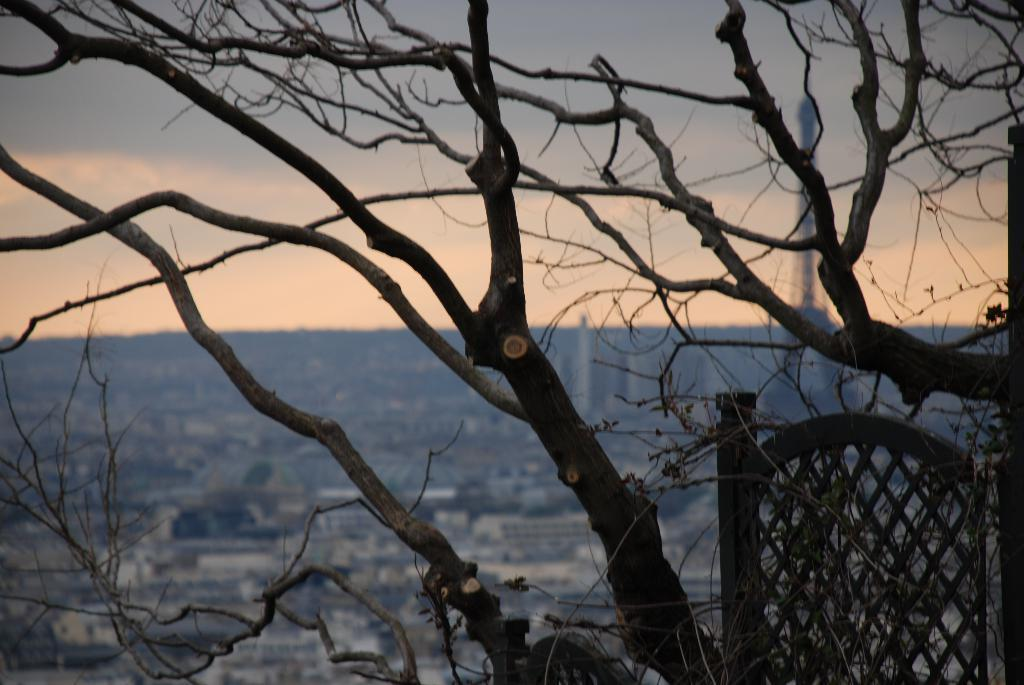What type of vegetation is present in the image? There are dried trees in the image. What can be seen in the distance behind the trees? There are buildings in the background of the image. What structure is located on the right side of the image? There is a tower on the right side of the image. What is visible in the sky in the image? The sky is visible in the background of the image. What type of breakfast is being served in the image? There is no breakfast present in the image; it features dried trees, buildings, a tower, and the sky. What religious belief is depicted in the image? There is no religious belief depicted in the image; it is a landscape featuring dried trees, buildings, a tower, and the sky. 